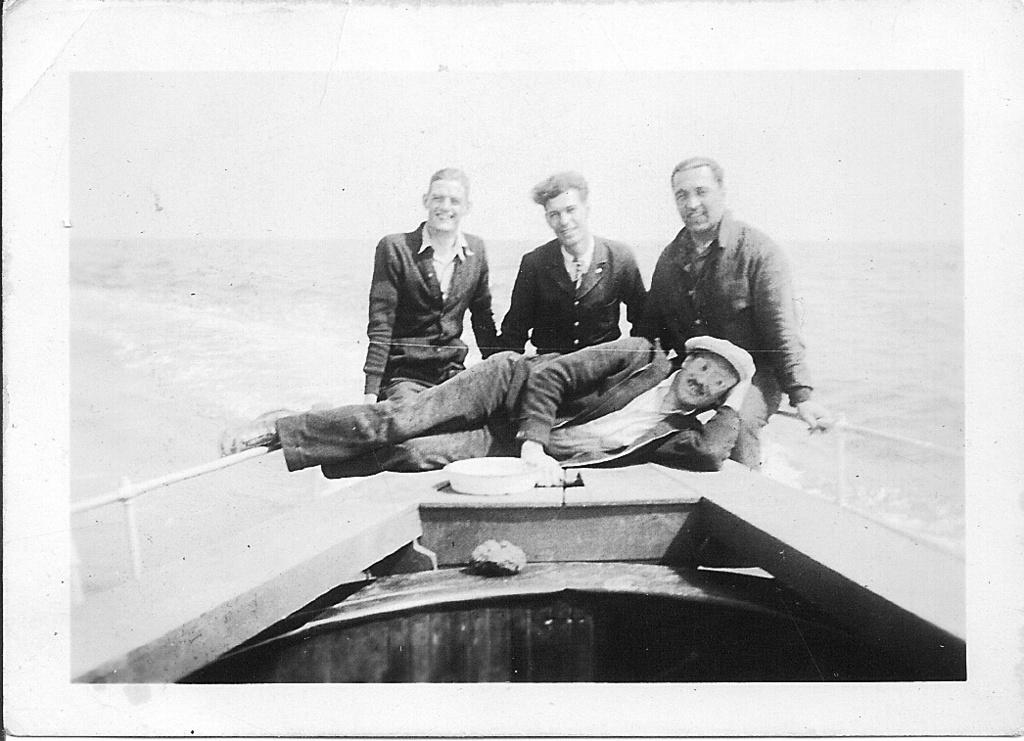What is the color scheme of the image? The image is black and white. How many people are sitting in the image? There are three people sitting in the image. What is the position of the man in the image? There is a man laying down in the image. What can be seen above the water in the image? There is a boat visible above the water in the image. How many clocks are hanging on the wall in the image? There are no clocks visible in the image. What type of bubble can be seen floating near the boat in the image? There is no bubble present in the image. 